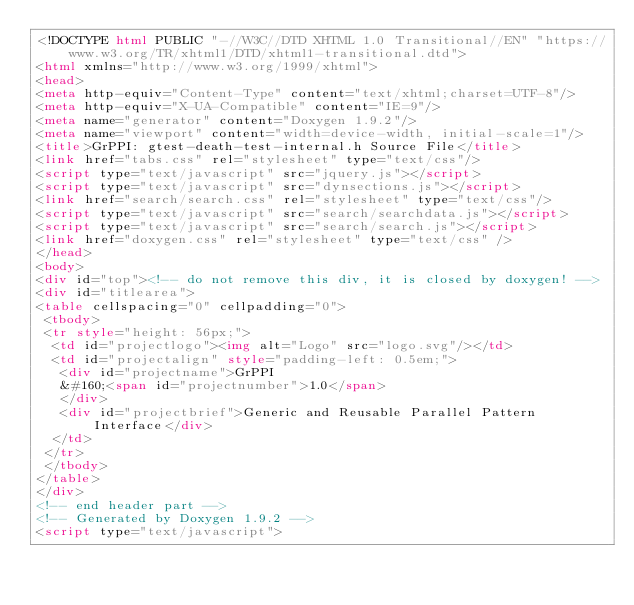Convert code to text. <code><loc_0><loc_0><loc_500><loc_500><_HTML_><!DOCTYPE html PUBLIC "-//W3C//DTD XHTML 1.0 Transitional//EN" "https://www.w3.org/TR/xhtml1/DTD/xhtml1-transitional.dtd">
<html xmlns="http://www.w3.org/1999/xhtml">
<head>
<meta http-equiv="Content-Type" content="text/xhtml;charset=UTF-8"/>
<meta http-equiv="X-UA-Compatible" content="IE=9"/>
<meta name="generator" content="Doxygen 1.9.2"/>
<meta name="viewport" content="width=device-width, initial-scale=1"/>
<title>GrPPI: gtest-death-test-internal.h Source File</title>
<link href="tabs.css" rel="stylesheet" type="text/css"/>
<script type="text/javascript" src="jquery.js"></script>
<script type="text/javascript" src="dynsections.js"></script>
<link href="search/search.css" rel="stylesheet" type="text/css"/>
<script type="text/javascript" src="search/searchdata.js"></script>
<script type="text/javascript" src="search/search.js"></script>
<link href="doxygen.css" rel="stylesheet" type="text/css" />
</head>
<body>
<div id="top"><!-- do not remove this div, it is closed by doxygen! -->
<div id="titlearea">
<table cellspacing="0" cellpadding="0">
 <tbody>
 <tr style="height: 56px;">
  <td id="projectlogo"><img alt="Logo" src="logo.svg"/></td>
  <td id="projectalign" style="padding-left: 0.5em;">
   <div id="projectname">GrPPI
   &#160;<span id="projectnumber">1.0</span>
   </div>
   <div id="projectbrief">Generic and Reusable Parallel Pattern Interface</div>
  </td>
 </tr>
 </tbody>
</table>
</div>
<!-- end header part -->
<!-- Generated by Doxygen 1.9.2 -->
<script type="text/javascript"></code> 